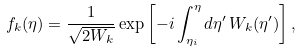Convert formula to latex. <formula><loc_0><loc_0><loc_500><loc_500>f _ { k } ( \eta ) = \frac { 1 } { \sqrt { 2 W _ { k } } } \exp \left [ - i \int ^ { \eta } _ { \eta _ { i } } d \eta ^ { \prime } \, W _ { k } ( \eta ^ { \prime } ) \right ] ,</formula> 